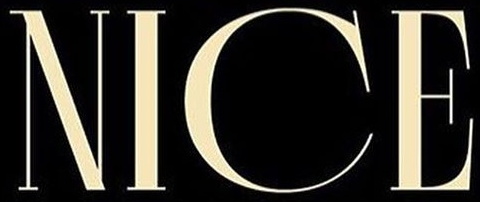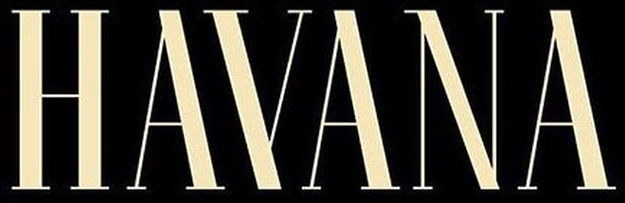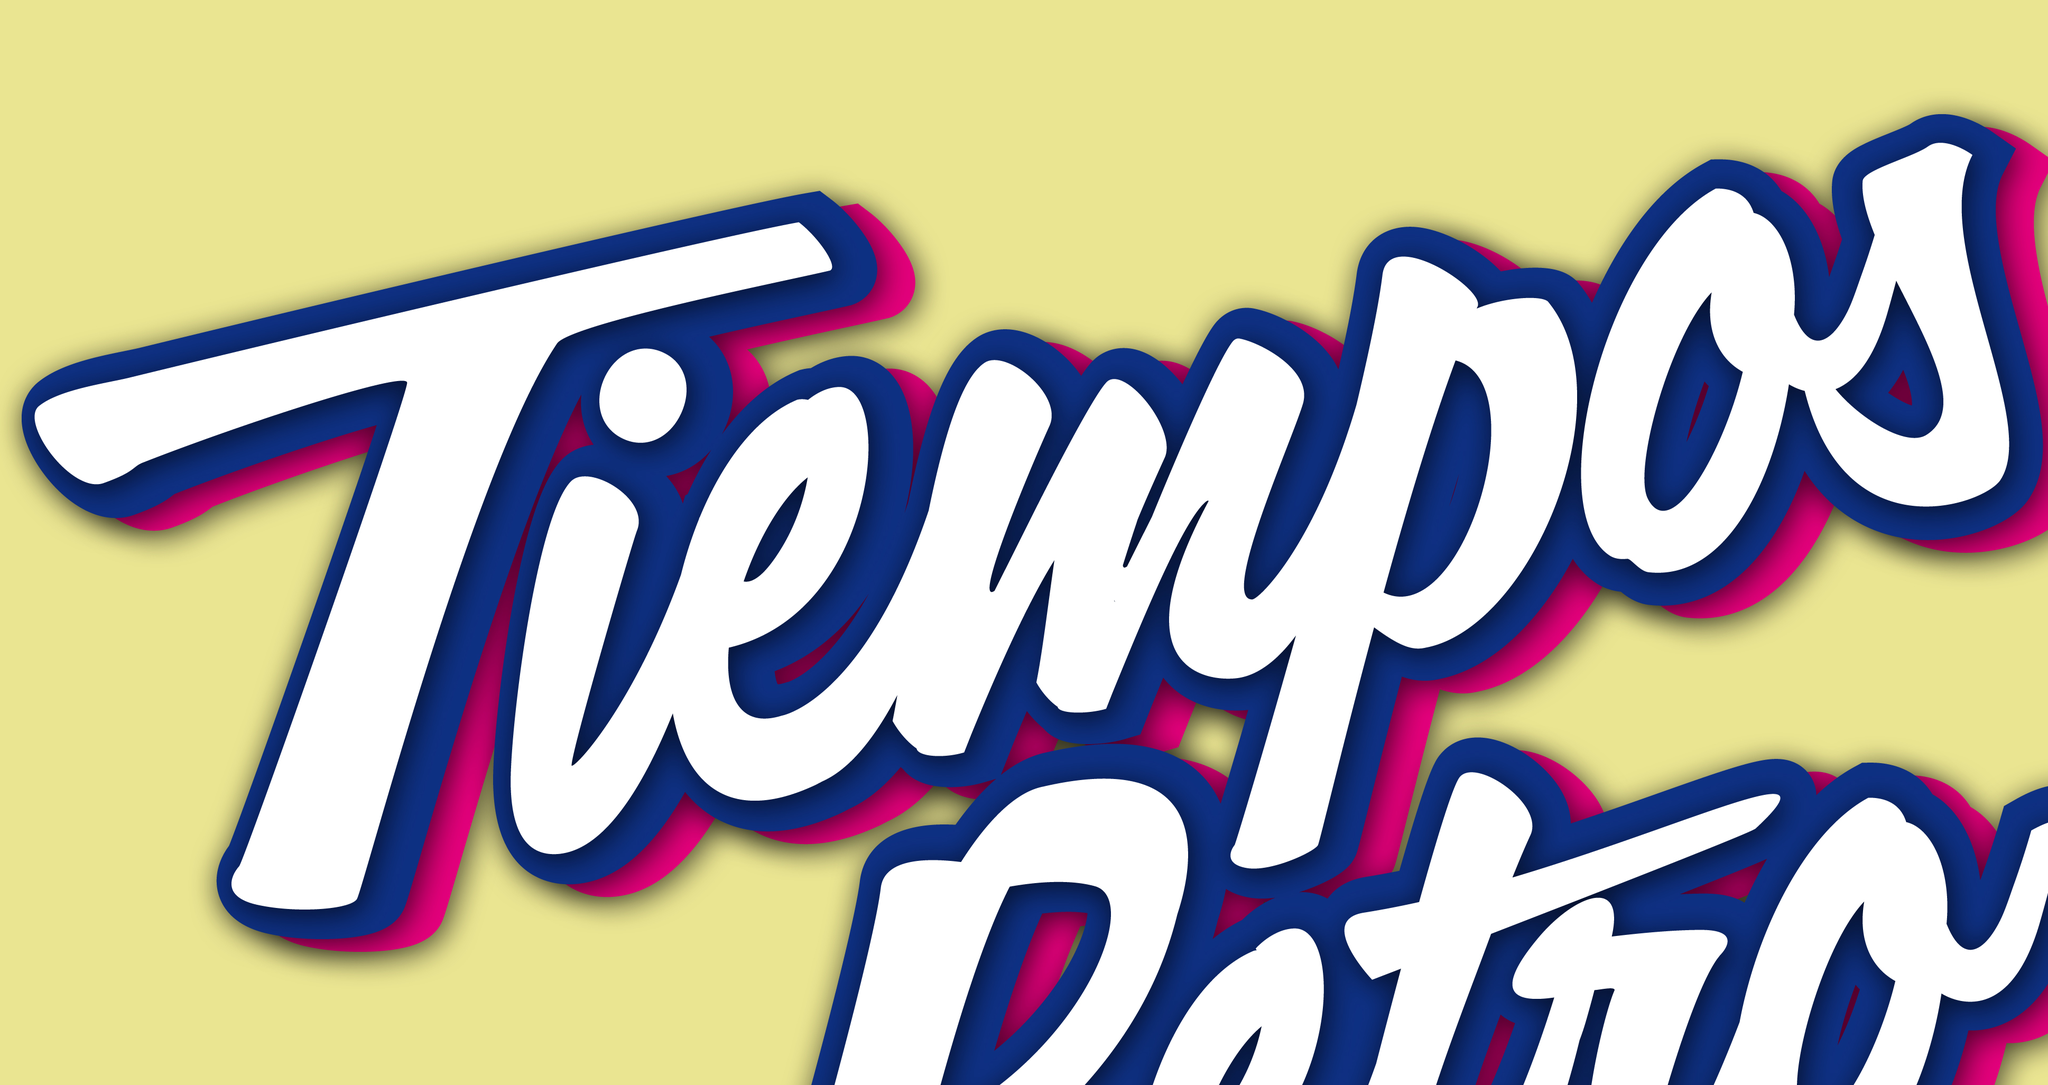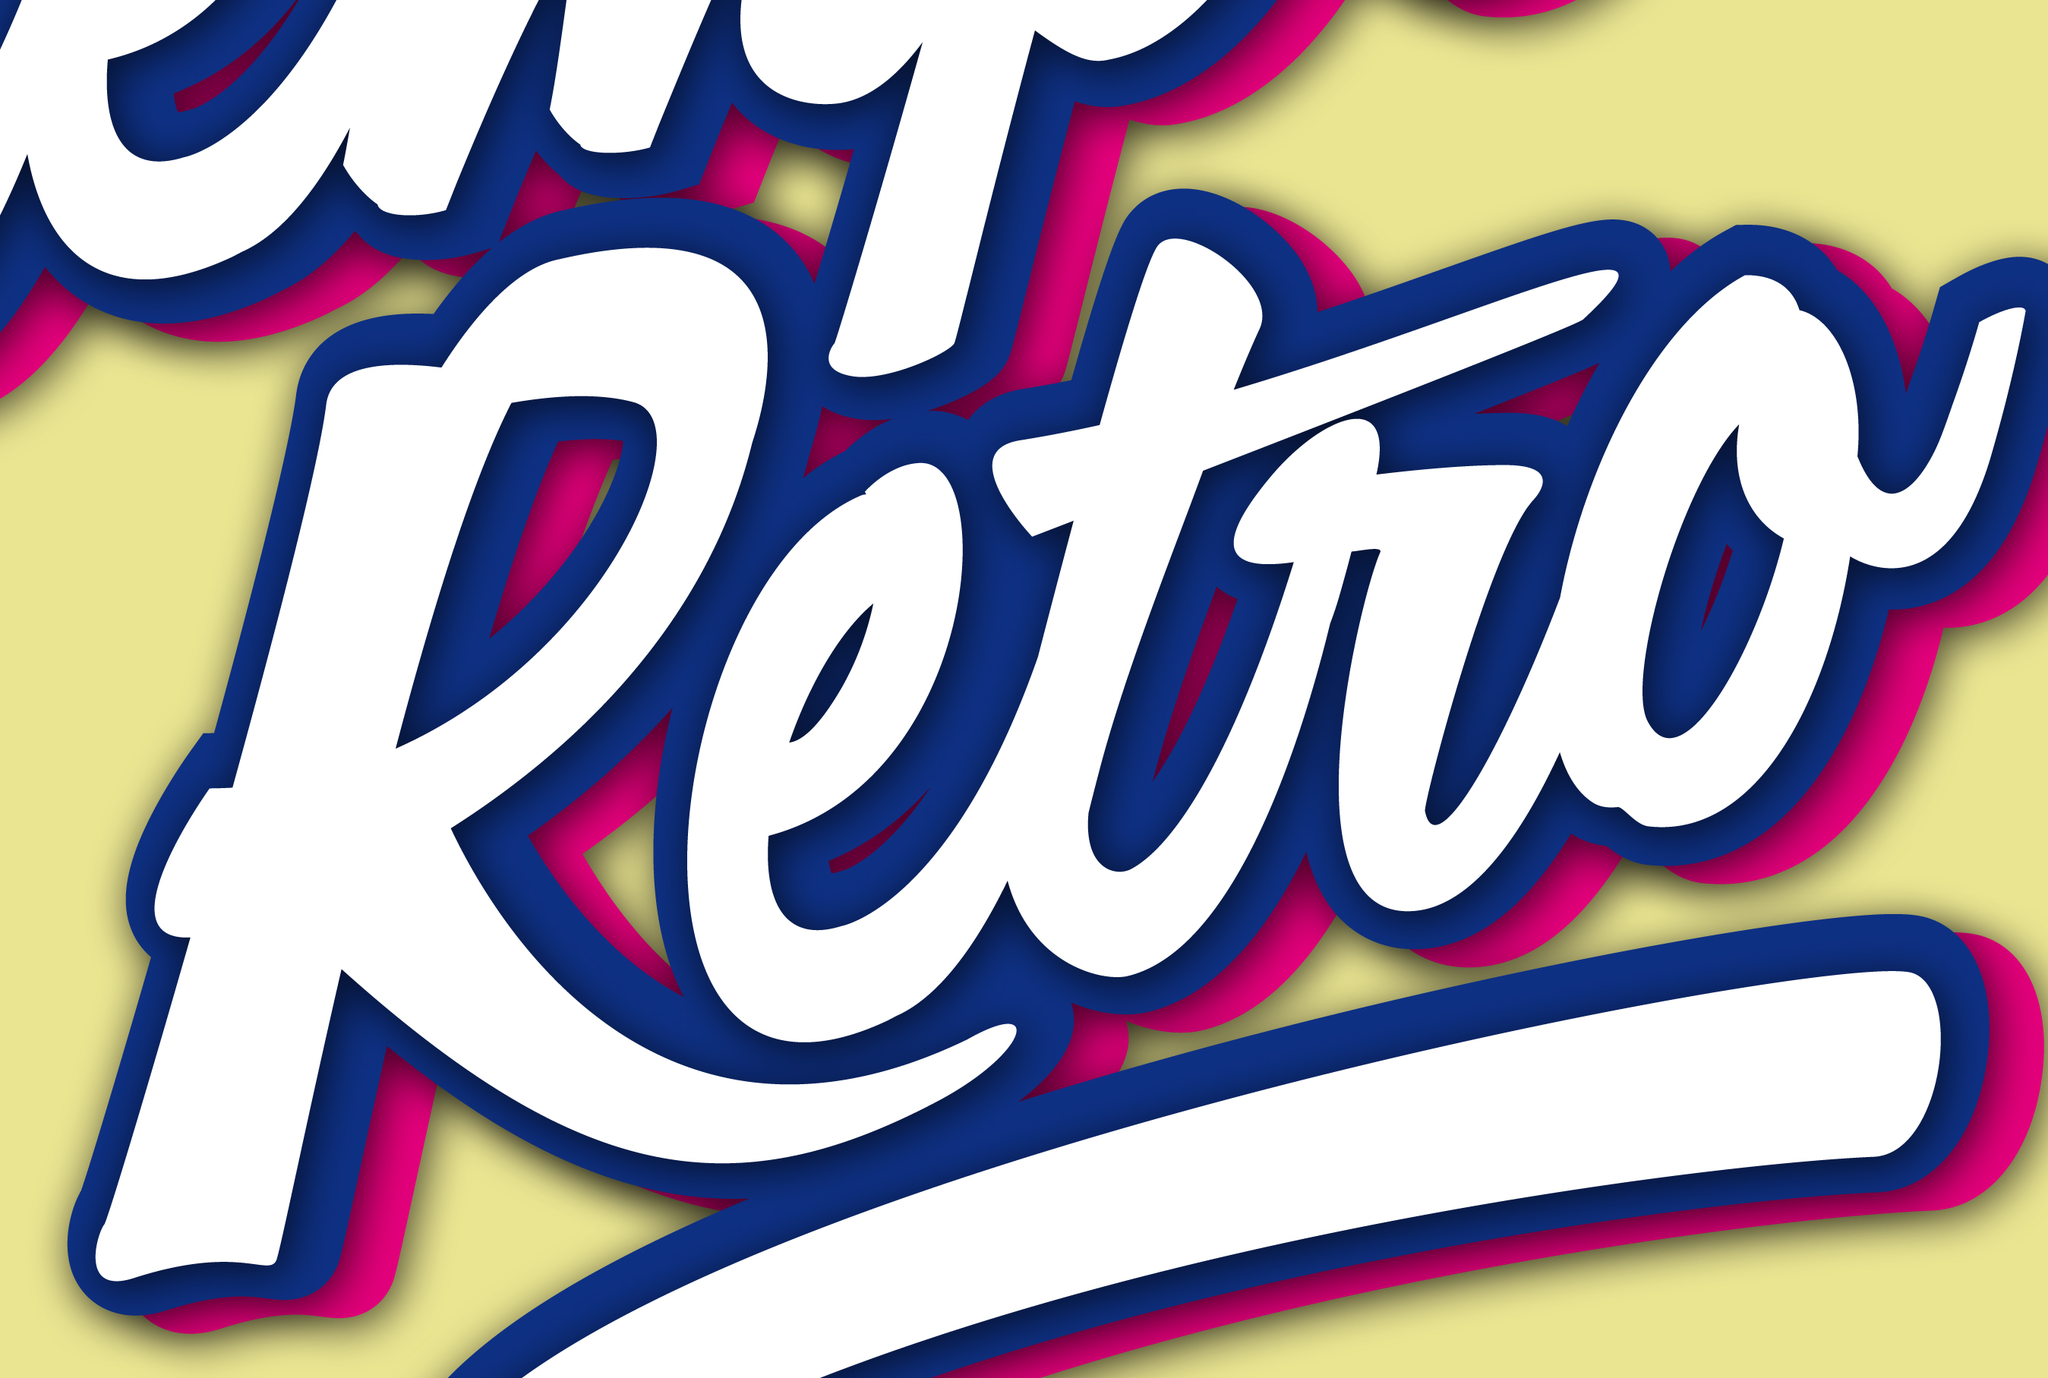What words are shown in these images in order, separated by a semicolon? NICE; HAYANA; Tiempos; Retro 